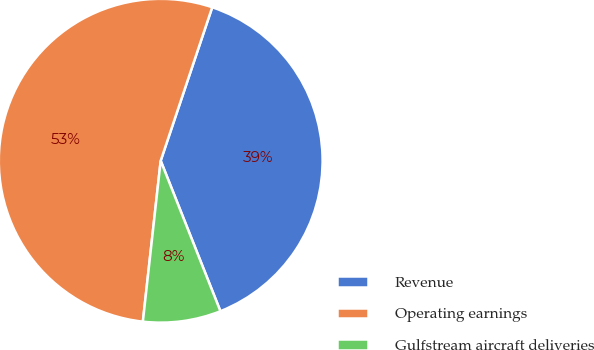Convert chart. <chart><loc_0><loc_0><loc_500><loc_500><pie_chart><fcel>Revenue<fcel>Operating earnings<fcel>Gulfstream aircraft deliveries<nl><fcel>38.83%<fcel>53.4%<fcel>7.77%<nl></chart> 